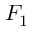<formula> <loc_0><loc_0><loc_500><loc_500>F _ { 1 }</formula> 